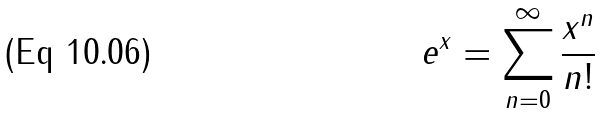<formula> <loc_0><loc_0><loc_500><loc_500>e ^ { x } = \sum _ { n = 0 } ^ { \infty } \frac { x ^ { n } } { n ! }</formula> 